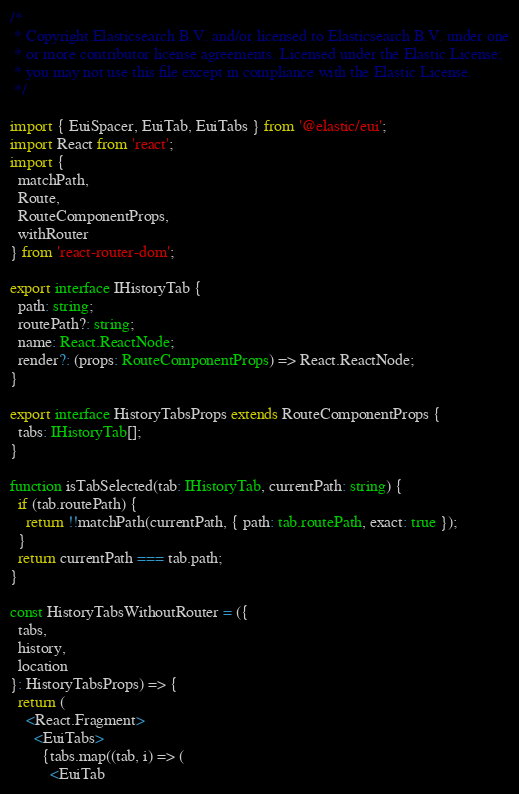Convert code to text. <code><loc_0><loc_0><loc_500><loc_500><_TypeScript_>/*
 * Copyright Elasticsearch B.V. and/or licensed to Elasticsearch B.V. under one
 * or more contributor license agreements. Licensed under the Elastic License;
 * you may not use this file except in compliance with the Elastic License.
 */

import { EuiSpacer, EuiTab, EuiTabs } from '@elastic/eui';
import React from 'react';
import {
  matchPath,
  Route,
  RouteComponentProps,
  withRouter
} from 'react-router-dom';

export interface IHistoryTab {
  path: string;
  routePath?: string;
  name: React.ReactNode;
  render?: (props: RouteComponentProps) => React.ReactNode;
}

export interface HistoryTabsProps extends RouteComponentProps {
  tabs: IHistoryTab[];
}

function isTabSelected(tab: IHistoryTab, currentPath: string) {
  if (tab.routePath) {
    return !!matchPath(currentPath, { path: tab.routePath, exact: true });
  }
  return currentPath === tab.path;
}

const HistoryTabsWithoutRouter = ({
  tabs,
  history,
  location
}: HistoryTabsProps) => {
  return (
    <React.Fragment>
      <EuiTabs>
        {tabs.map((tab, i) => (
          <EuiTab</code> 